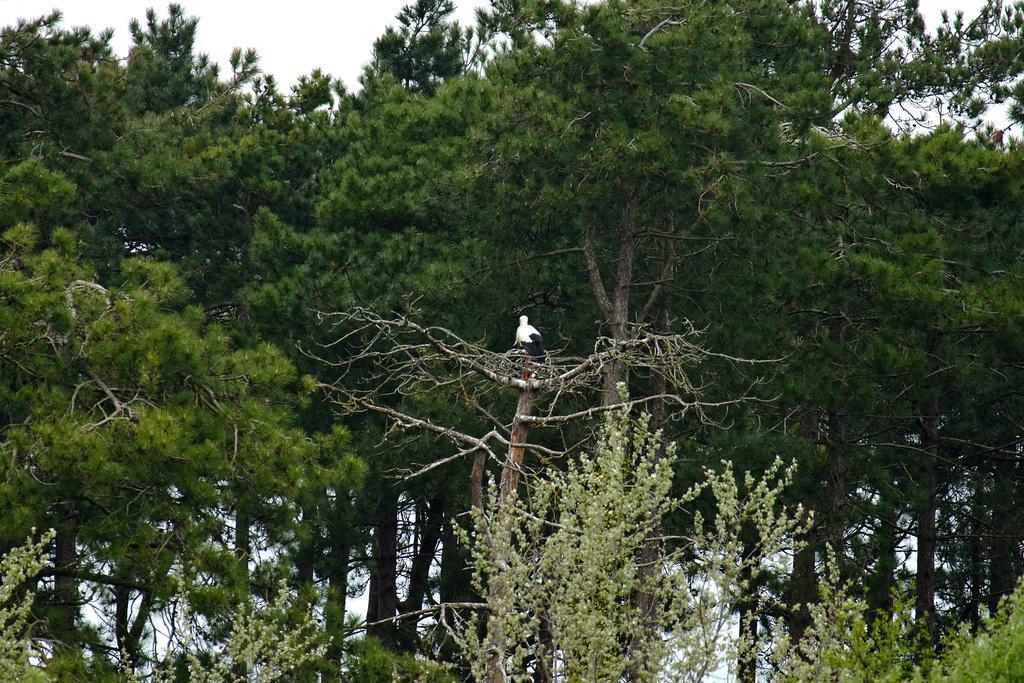Can you describe this image briefly? In this picture there is a bird on the tree and the bird is in white and in black color. At the back there are trees. At the top there is sky. 